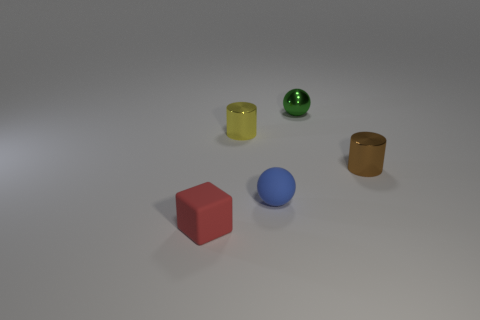Add 3 small purple shiny cubes. How many objects exist? 8 Subtract all green spheres. How many spheres are left? 1 Subtract all cubes. How many objects are left? 4 Subtract 2 cylinders. How many cylinders are left? 0 Subtract all gray cubes. Subtract all small yellow metallic things. How many objects are left? 4 Add 5 tiny spheres. How many tiny spheres are left? 7 Add 1 green rubber things. How many green rubber things exist? 1 Subtract 0 green cubes. How many objects are left? 5 Subtract all green balls. Subtract all purple cylinders. How many balls are left? 1 